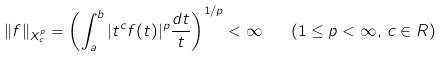Convert formula to latex. <formula><loc_0><loc_0><loc_500><loc_500>\| f \| _ { X ^ { p } _ { c } } = \left ( \int ^ { b } _ { a } | t ^ { c } f ( t ) | ^ { p } \frac { d t } { t } \right ) ^ { 1 / p } < \infty \quad ( 1 \leq p < \infty , \, c \in R )</formula> 